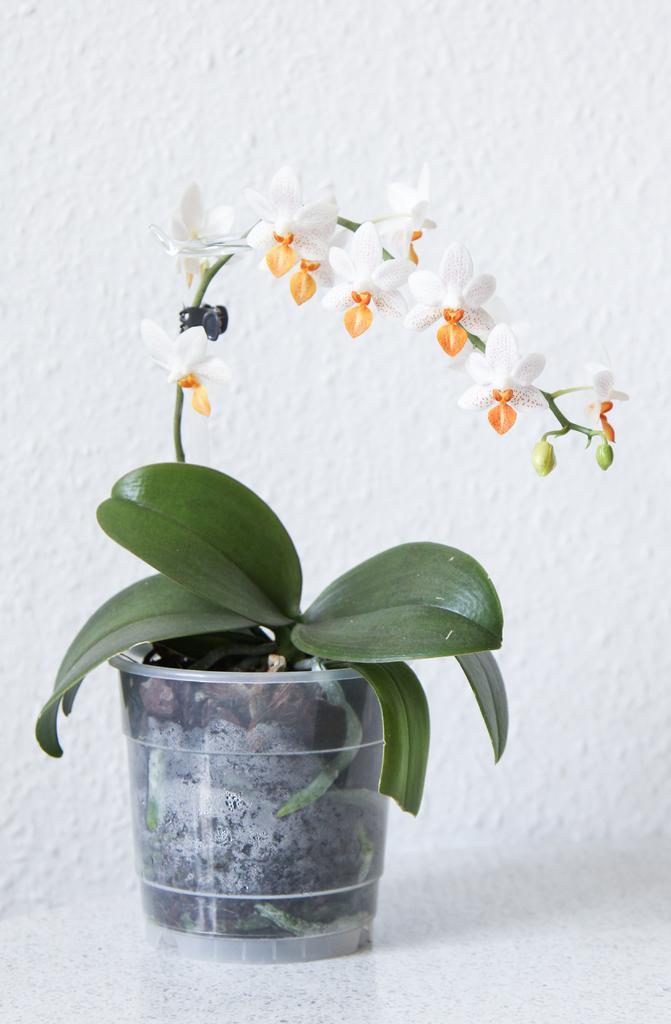Please provide a concise description of this image. At the bottom of this image, there is a potted plant, having green color leaves and white colored flowers, placed on a surface. And the background is white in color. 